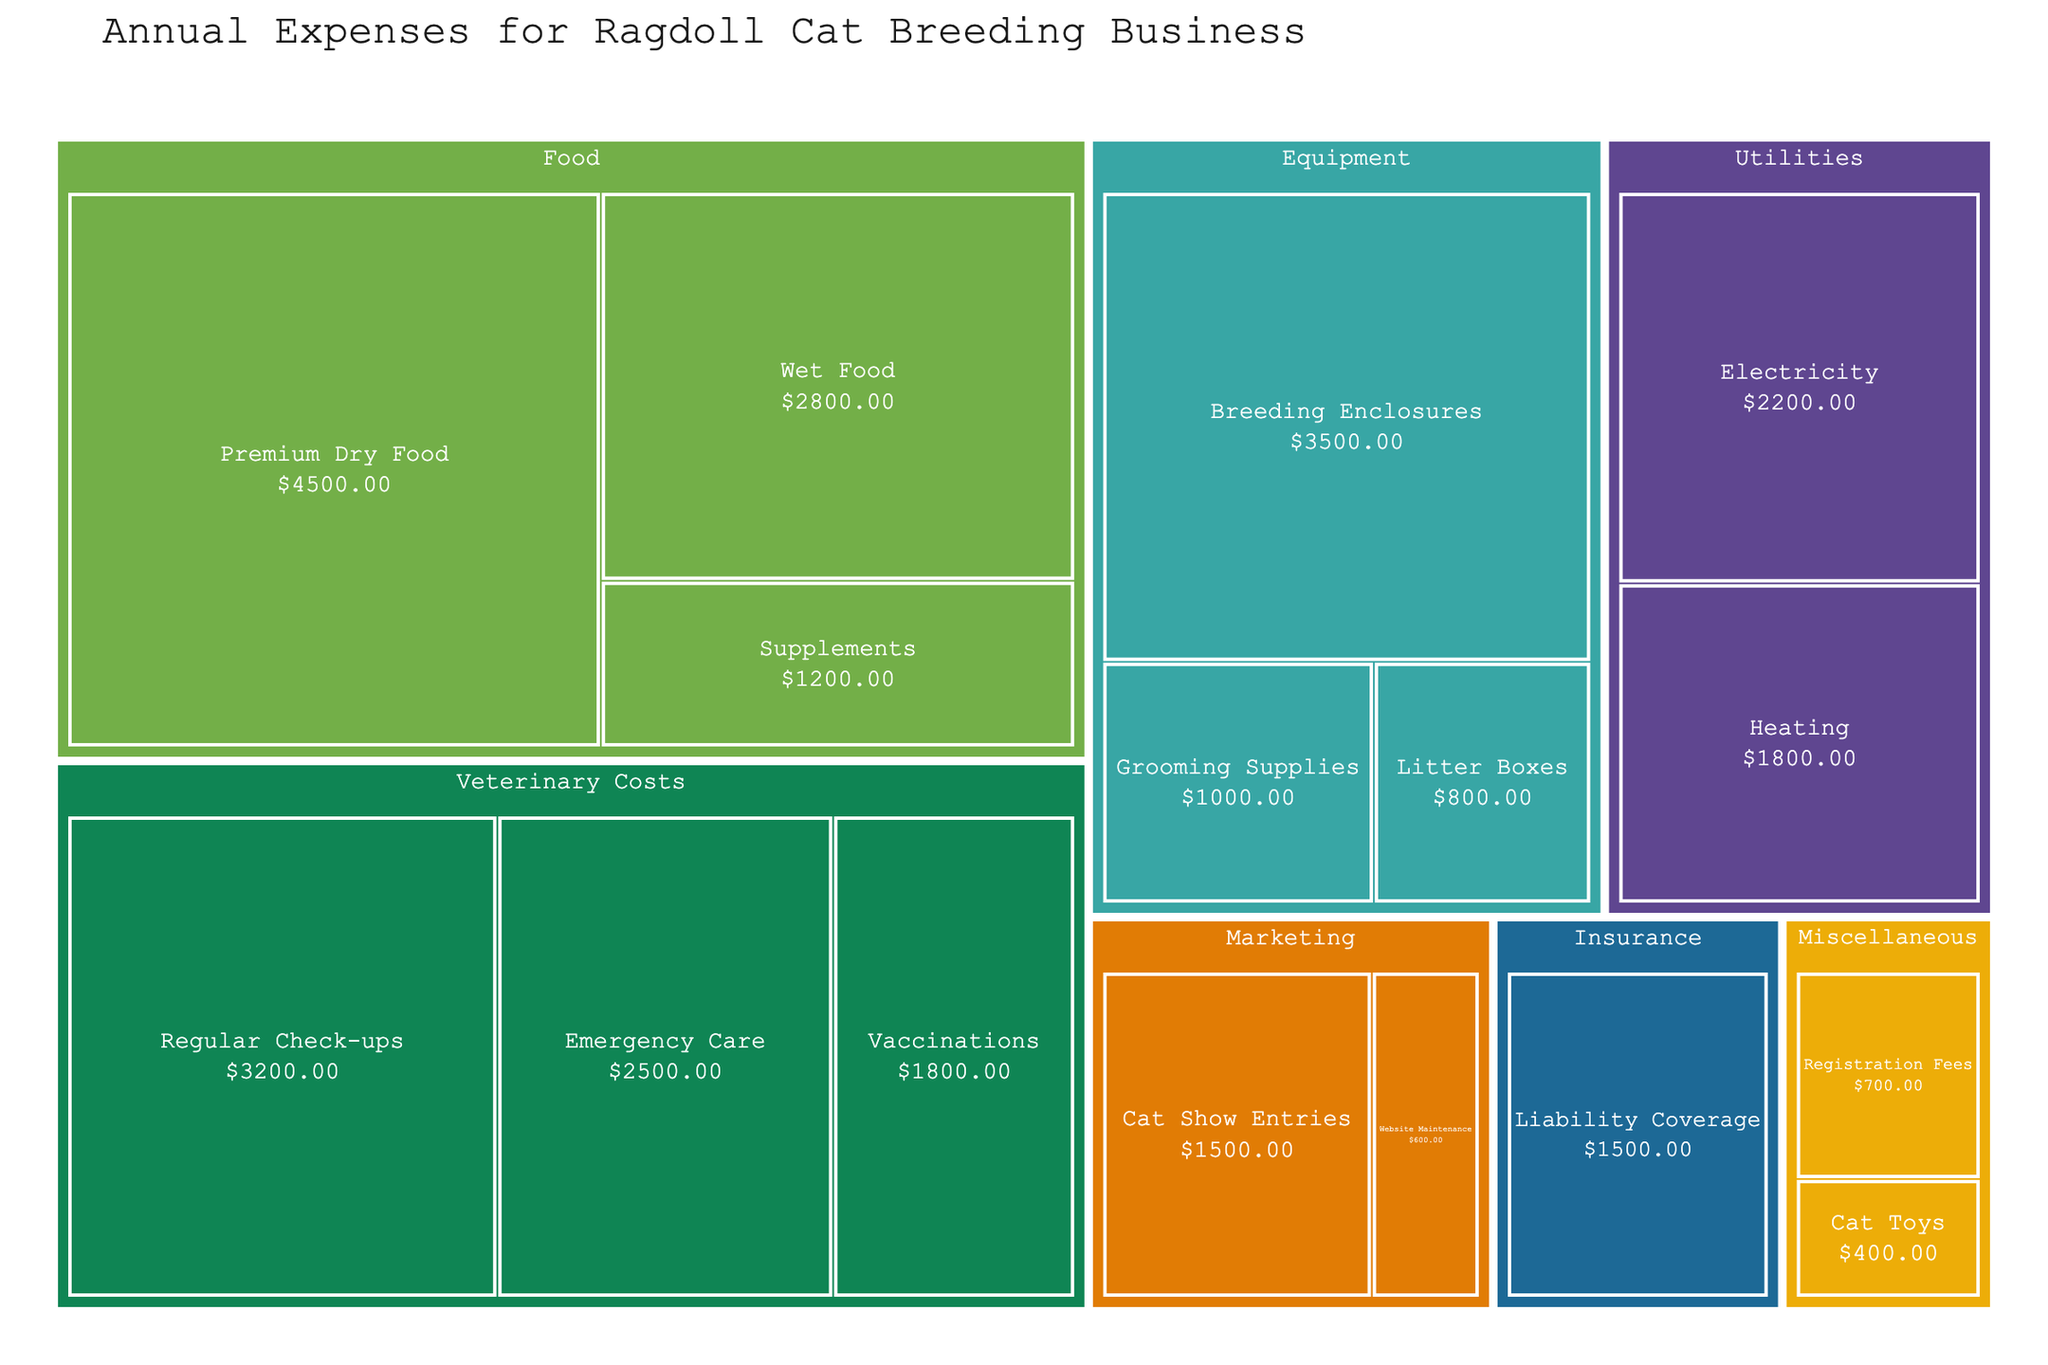What is the title of the figure? The title is displayed at the top of the treemap, which is the primary indicator of the main topic of the figure.
Answer: Annual Expenses for Ragdoll Cat Breeding Business What category has the highest total expense? Compare the sum of subcategory amounts within each main category. Food sums to 4500 + 2800 + 1200 = 8500, Veterinary Costs sums to 3200 + 1800 + 2500 = 7500, and others are less.
Answer: Food Which subcategory has the largest single expense? Visually scan for the largest box or perform a pairwise comparison of all subcategories. Premium Dry Food has an amount of $4500, which is the highest among all subcategories.
Answer: Premium Dry Food What is the total amount spent on Veterinary Costs? Sum the expenses under the subcategories of Veterinary Costs: Regular Check-ups (3200) + Vaccinations (1800) + Emergency Care (2500). 3200 + 1800 + 2500 = 7500
Answer: 7500 How does the expense on Heating compare to that on Electricity? Compare the amounts under the Utilities category. Heating is 1800 and Electricity is 2200. 1800 is less than 2200.
Answer: Less If we combine Marketing and Miscellaneous categories, what is their total expense? Add all subcategory amounts within Marketing and Miscellaneous. Marketing: 600 + 1500; Miscellaneous: 400 + 700. 600 + 1500 + 400 + 700 = 3200
Answer: 3200 What are the three smallest subcategory expenses and their amounts? Identify the three smallest values in the subcategories list. Litter Boxes: 800, Grooming Supplies: 1000, and Website Maintenance: 600.
Answer: Website Maintenance: 600, Litter Boxes: 800, Grooming Supplies: 1000 What's the average expense for the Food category? Sum the amounts under Food and divide by the number of subcategories. (4500 + 2800 + 1200) / 3 = 8500 / 3 ≈ 2833.33
Answer: 2833.33 Which subcategory under Equipment has the lowest expense? Compare Grooming Supplies, Litter Boxes, and Breeding Enclosures. Litter Boxes have the lowest at 800.
Answer: Litter Boxes If Emergency Care expense increases by 20%, what will be the new total expense for Veterinary Costs? Calculate 20% of Emergency Care (0.20 * 2500 = 500) and add it to the original Emergency Care amount, then sum with other Veterinary Costs. New Emergency Care = 2500 + 500 = 3000. Total Veterinary Costs = 3200 + 1800 + 3000 = 8000.
Answer: 8000 